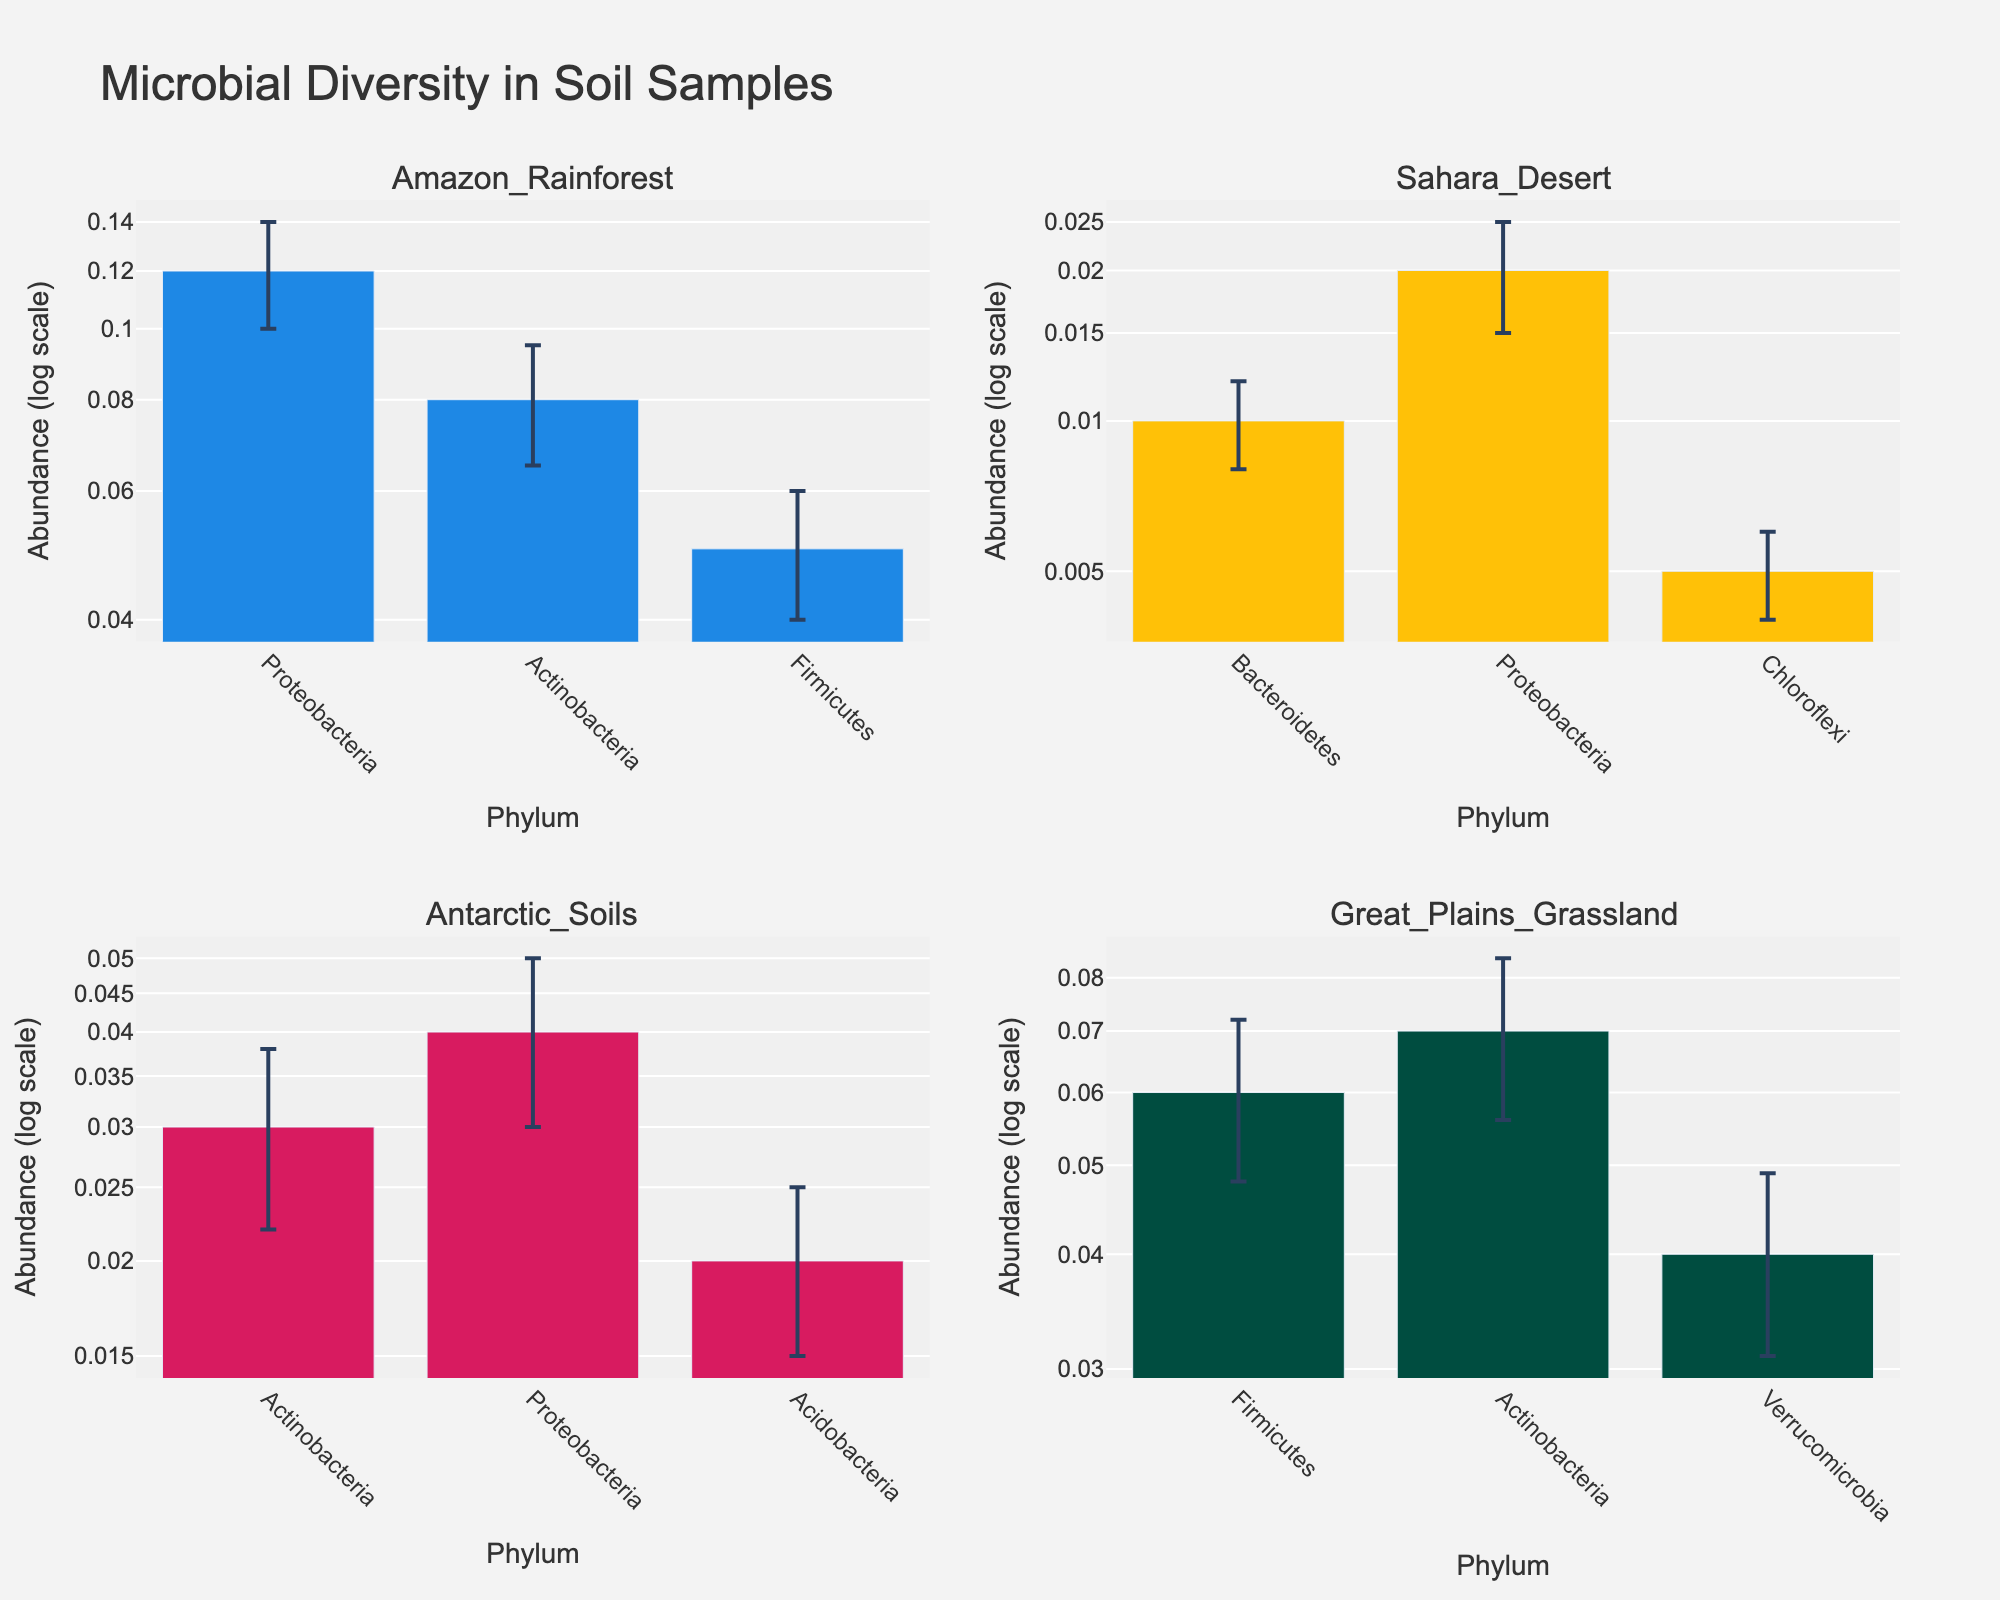What is the title of the figure? The title of the figure is displayed at the top center of the plot. It reads "Microbial Diversity in Soil Samples." This gives an overview of what the figure is about.
Answer: Microbial Diversity in Soil Samples What are the y-axis labels in the subplots indicating? The y-axis labels in the subplots indicate "Abundance (log scale)," which means the microbial abundance is represented on a logarithmic scale. This helps to manage the wide range of values in a more readable format.
Answer: Abundance (log scale) Which location shows the highest mean abundance of Proteobacteria? We need to look at each subplot to find the bar corresponding to Proteobacteria. The Amazon Rainforest subplot shows the highest mean abundance for Proteobacteria with a value of 0.12.
Answer: Amazon Rainforest How does the abundance of Actinobacteria in Antarctic Soils compare to that in the Great Plains Grassland? In Antarctic Soils, the abundance of Actinobacteria is 0.03 while in the Great Plains Grassland, it is 0.07. By comparing these values, 0.07 is greater than 0.03, indicating higher abundance in the Great Plains Grassland.
Answer: Greater in Great Plains Grassland Which phylum has the lowest mean abundance in the Sahara Desert? By examining the subplot for the Sahara Desert, we see that Chloroflexi has the lowest mean abundance at 0.005.
Answer: Chloroflexi Sum the mean abundances of all phyla in the Amazon Rainforest. In the Amazon Rainforest subplot, the mean abundances are: Proteobacteria (0.12), Actinobacteria (0.08), and Firmicutes (0.05). Summing these values: 0.12 + 0.08 + 0.05 = 0.25.
Answer: 0.25 What are the colors used to represent the different locations in the subplots? Each subplot uses a distinct color for the bars: blue for Amazon Rainforest, yellow for Sahara Desert, pink for Antarctic Soils, and green for Great Plains Grassland. This color differentiation helps in distinguishing the locations.
Answer: Blue, yellow, pink, green By how much does the mean abundance of Proteobacteria in the Amazon Rainforest exceed that in the Sahara Desert? The mean abundance of Proteobacteria in the Amazon Rainforest is 0.12, while in the Sahara Desert it is 0.02. The difference is 0.12 - 0.02 = 0.10.
Answer: 0.10 Which location has the greatest variance in abundance among its phyla, based on standard deviation? Variance can be inferred by comparing the lengths of the error bars in each subplot. The subplot with the largest error bars, indicating greater standard deviation, can be identified. The Great Plains Grassland has visibly longer error bars overall.
Answer: Great Plains Grassland 